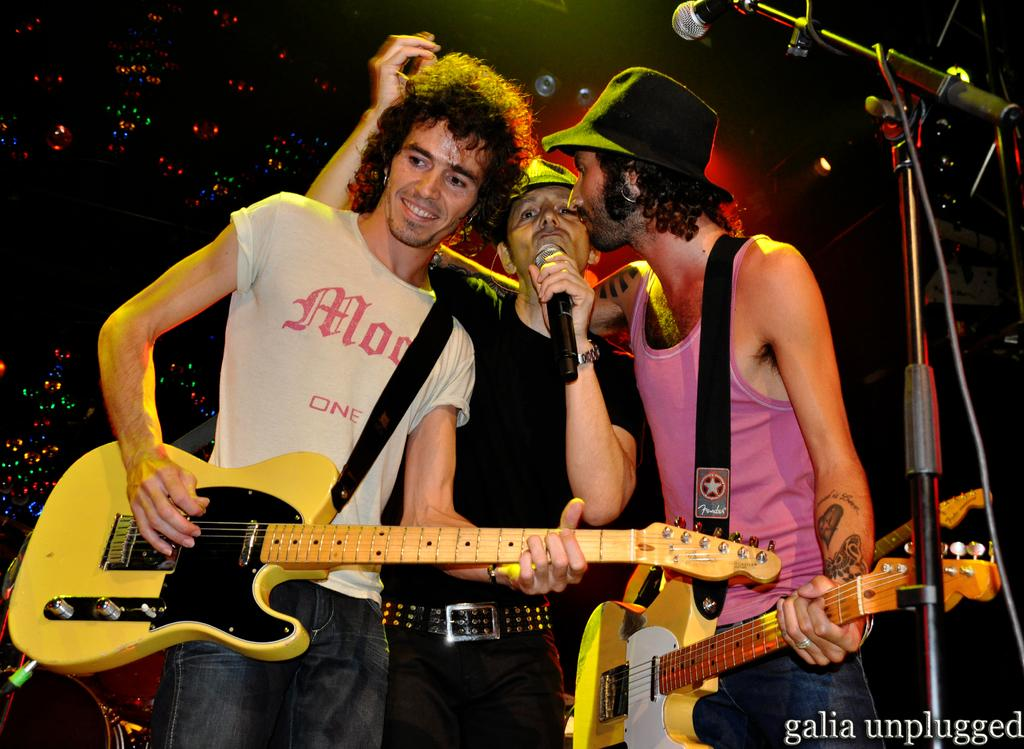How many people are in the image? There are three men in the image. What are two of the men holding? Two of the men are holding guitars. What is the third man holding? The third man is holding a microphone in his hand. Are there any other microphones visible in the image? Yes, there is another microphone visible in the image. What type of umbrella is being used as a prop in the image? There is no umbrella present in the image. Are the men in the image planning an attack on someone? There is no indication of an attack or any aggressive behavior in the image. 